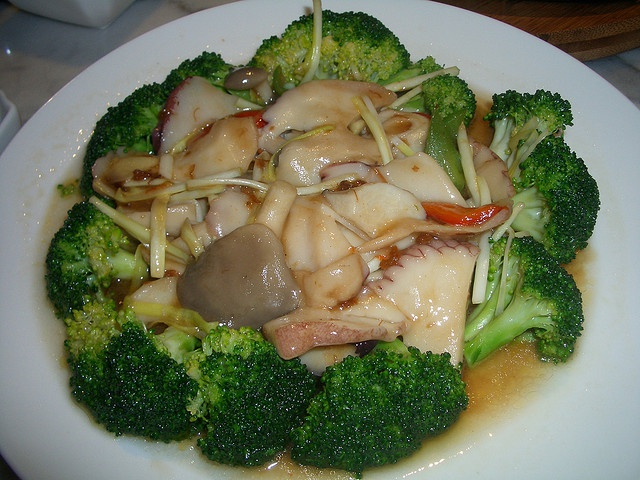Describe the objects in this image and their specific colors. I can see bowl in darkgray, black, tan, and olive tones, broccoli in black, darkgreen, and olive tones, broccoli in black and darkgreen tones, broccoli in black and darkgreen tones, and broccoli in black, olive, darkgreen, and gray tones in this image. 